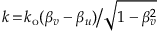Convert formula to latex. <formula><loc_0><loc_0><loc_500><loc_500>k \, = \, k _ { o } ( \beta _ { v } - \beta _ { u } ) \Big / \sqrt { 1 - \beta _ { v } ^ { 2 } }</formula> 